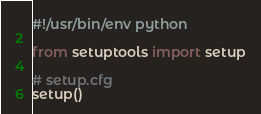<code> <loc_0><loc_0><loc_500><loc_500><_Python_>#!/usr/bin/env python

from setuptools import setup

# setup.cfg
setup()
</code> 